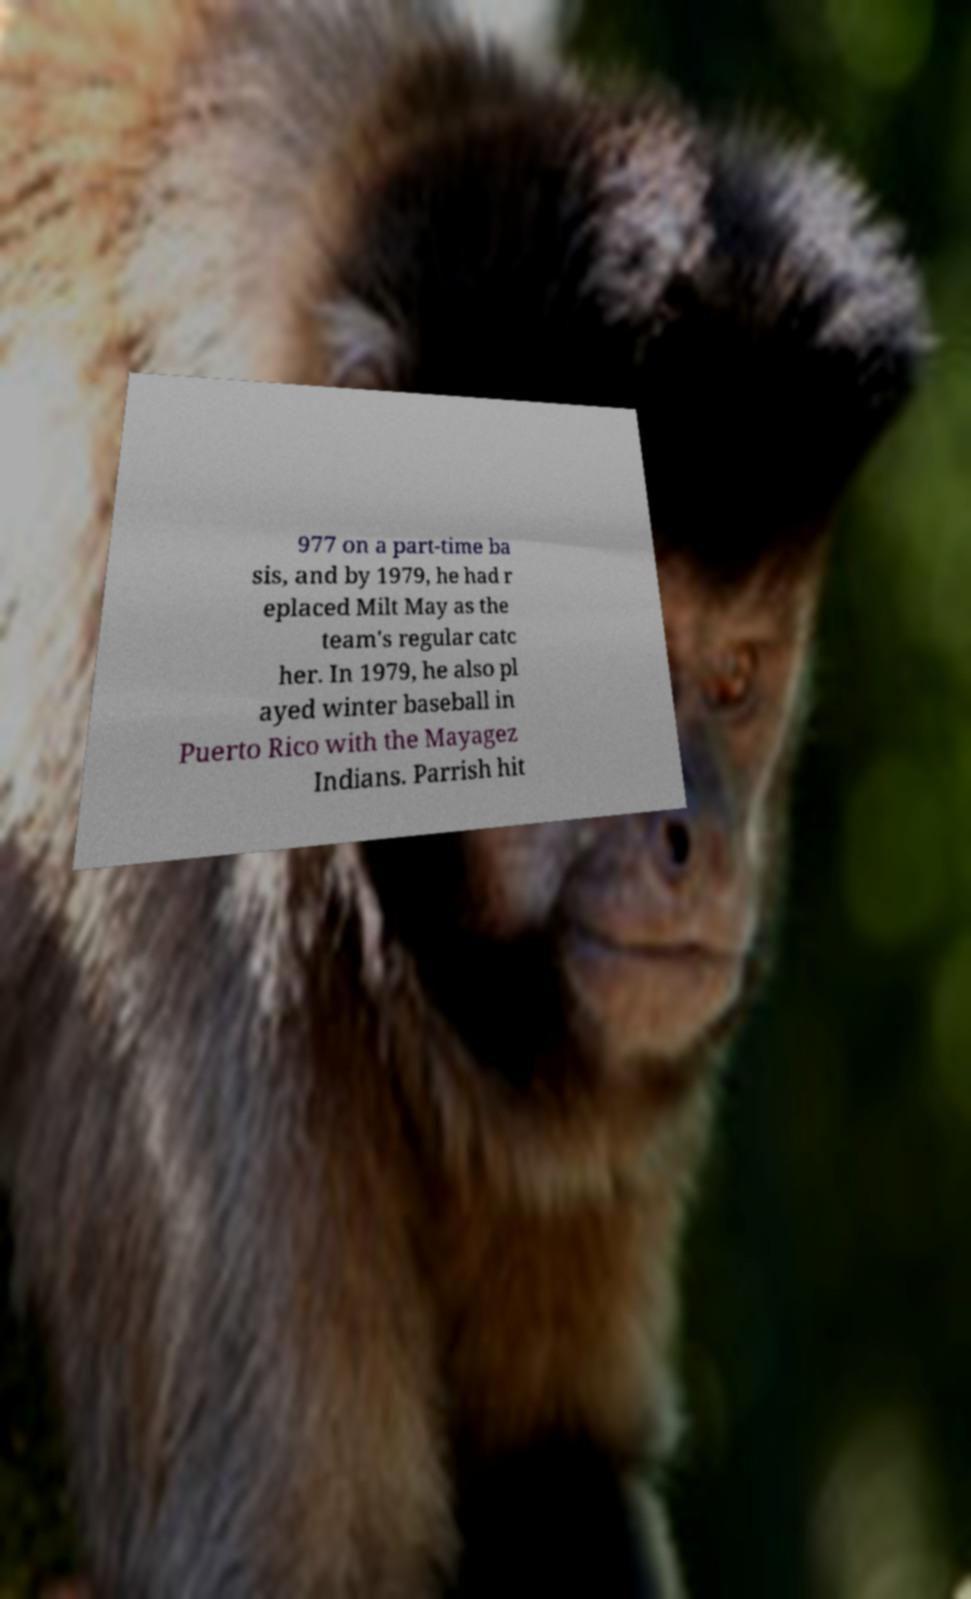Could you assist in decoding the text presented in this image and type it out clearly? 977 on a part-time ba sis, and by 1979, he had r eplaced Milt May as the team's regular catc her. In 1979, he also pl ayed winter baseball in Puerto Rico with the Mayagez Indians. Parrish hit 